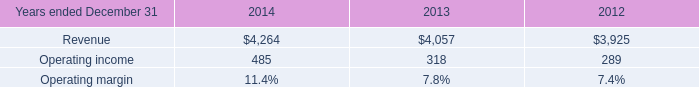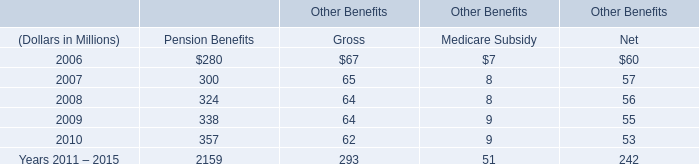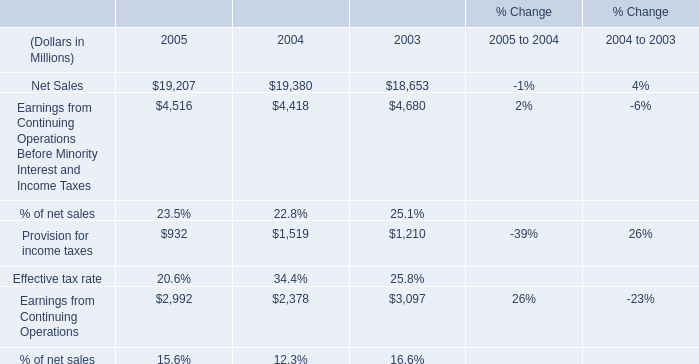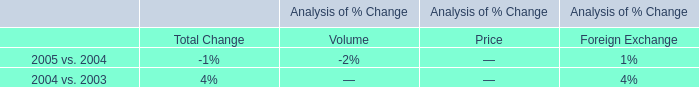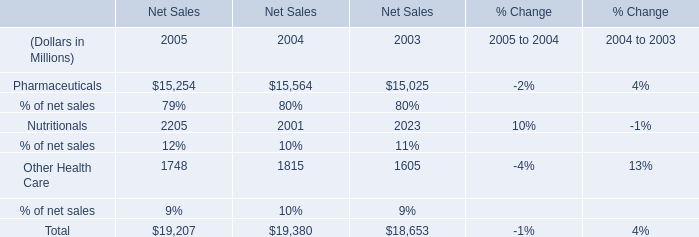Which year is Other Health Care the most for Net Sales? 
Answer: 2004. 